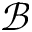<formula> <loc_0><loc_0><loc_500><loc_500>\mathcal { B }</formula> 